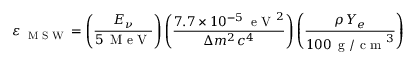<formula> <loc_0><loc_0><loc_500><loc_500>\varepsilon _ { M S W } = \left ( \frac { E _ { \nu } } { 5 \, M e V } \right ) \left ( \frac { 7 . 7 \times 1 0 ^ { - 5 } \, { e V ^ { 2 } } } { \Delta m ^ { 2 } \, c ^ { 4 } } \right ) \left ( \frac { \rho \, Y _ { e } } { 1 0 0 \, g / c m ^ { 3 } } \right )</formula> 